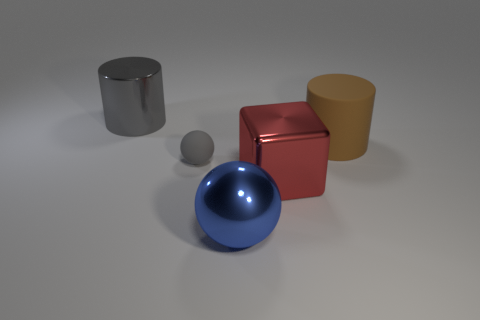Is there anything else of the same color as the rubber ball?
Offer a terse response. Yes. Do the cube and the matte sphere have the same color?
Provide a succinct answer. No. How many red things are either tiny metallic spheres or cylinders?
Your answer should be very brief. 0. Is the number of large blue metallic things that are behind the big blue metal object less than the number of red cylinders?
Make the answer very short. No. There is a cylinder left of the brown cylinder; how many big gray objects are on the left side of it?
Provide a succinct answer. 0. How many other things are the same size as the shiny cube?
Make the answer very short. 3. What number of things are either big brown cylinders or big cylinders that are left of the large ball?
Give a very brief answer. 2. Are there fewer green matte spheres than big cylinders?
Keep it short and to the point. Yes. The big cylinder that is in front of the big cylinder left of the big blue metallic ball is what color?
Ensure brevity in your answer.  Brown. There is another thing that is the same shape as the brown matte object; what material is it?
Provide a short and direct response. Metal. 